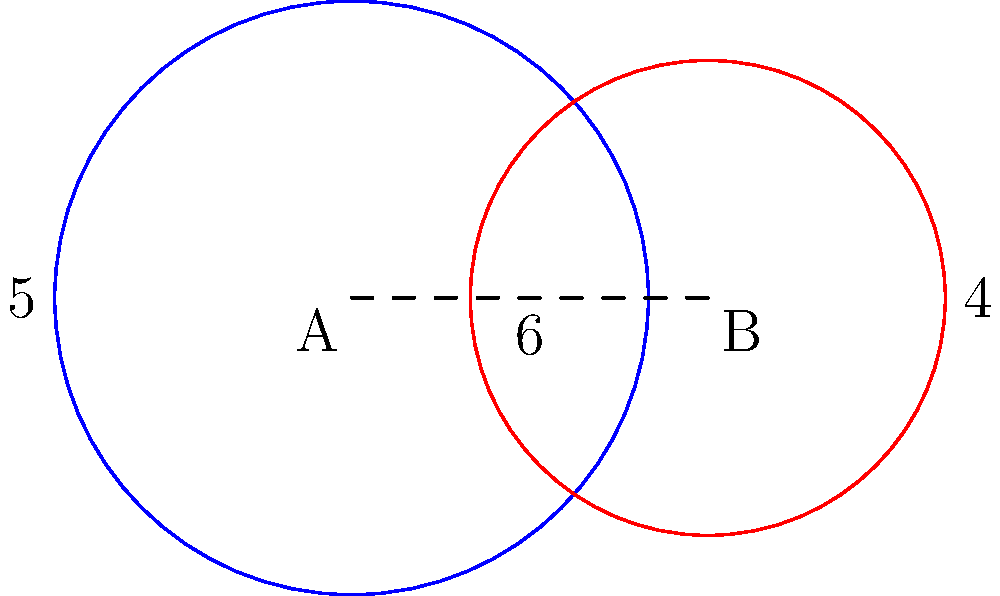In thy fields of providence, thou hast two circular crop areas that overlap. The first, centered at point A, hath a radius of 5 rods, while the second, centered at point B, hath a radius of 4 rods. The distance between the centers is 6 rods. Calculate the area of overlap between these two fields, as it may represent the bounty of our shared labors. Express thy answer in square rods, rounded to two decimal places. To find the area of overlap between two circles, we shall follow these steps as guided by divine wisdom:

1. First, we must calculate the distance from each circle's center to the chord of intersection:
   For circle A: $a = \frac{5^2 - 4^2 + 6^2}{2(6)} = 3.958$ rods
   For circle B: $b = 6 - 3.958 = 2.042$ rods

2. Now, we shall find the central angle for each circle:
   For circle A: $\theta_1 = 2 \arccos(\frac{3.958}{5}) = 2.2143$ radians
   For circle B: $\theta_2 = 2 \arccos(\frac{2.042}{4}) = 2.2143$ radians

3. The area of each sector is:
   Sector A: $A_1 = \frac{1}{2} (5^2) (2.2143) = 27.6788$ sq rods
   Sector B: $A_2 = \frac{1}{2} (4^2) (2.2143) = 17.7144$ sq rods

4. The area of each triangle is:
   Triangle A: $T_1 = \frac{1}{2} (5) (5 \sin(\frac{2.2143}{2})) = 9.7920$ sq rods
   Triangle B: $T_2 = \frac{1}{2} (4) (4 \sin(\frac{2.2143}{2})) = 6.2669$ sq rods

5. The area of overlap is the sum of the sectors minus the sum of the triangles:
   Overlap Area = $(A_1 + A_2) - (T_1 + T_2)$
                = $(27.6788 + 17.7144) - (9.7920 + 6.2669)$
                = $45.3932 - 16.0589$
                = $29.3343$ sq rods

6. Rounding to two decimal places: 29.33 sq rods
Answer: 29.33 sq rods 